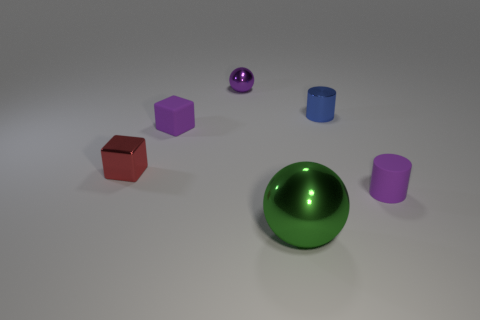Is there any other thing that has the same size as the green metallic thing?
Make the answer very short. No. What number of big things are green spheres or metallic cylinders?
Your answer should be compact. 1. The small cylinder in front of the purple matte thing on the left side of the shiny sphere that is behind the large metal sphere is what color?
Give a very brief answer. Purple. What number of other things are the same color as the tiny metal ball?
Provide a short and direct response. 2. How many matte things are green things or purple spheres?
Provide a succinct answer. 0. There is a tiny metal thing that is in front of the tiny blue thing; does it have the same color as the small cylinder right of the tiny blue metal thing?
Offer a terse response. No. The purple rubber thing that is the same shape as the blue thing is what size?
Offer a very short reply. Small. Are there more small metal cylinders left of the tiny blue shiny thing than rubber things?
Offer a terse response. No. Does the purple thing that is in front of the tiny metallic cube have the same material as the blue cylinder?
Offer a very short reply. No. There is a metallic thing on the left side of the purple object behind the purple rubber object behind the tiny red metal block; how big is it?
Your response must be concise. Small. 